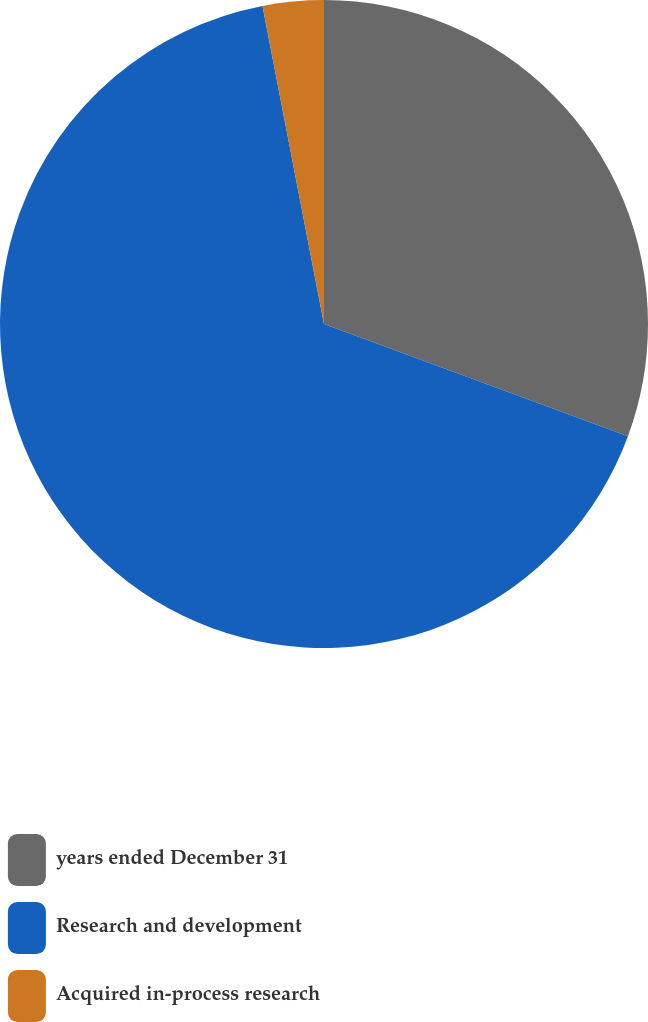Convert chart. <chart><loc_0><loc_0><loc_500><loc_500><pie_chart><fcel>years ended December 31<fcel>Research and development<fcel>Acquired in-process research<nl><fcel>30.63%<fcel>66.33%<fcel>3.04%<nl></chart> 